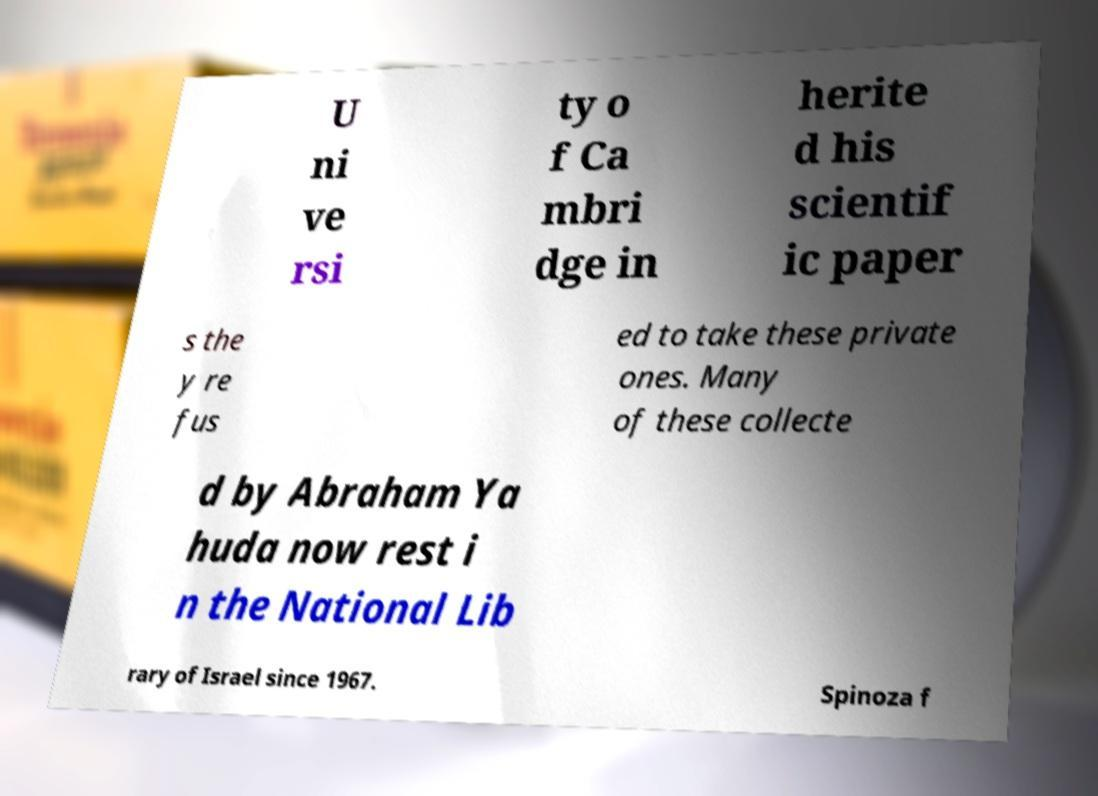What messages or text are displayed in this image? I need them in a readable, typed format. U ni ve rsi ty o f Ca mbri dge in herite d his scientif ic paper s the y re fus ed to take these private ones. Many of these collecte d by Abraham Ya huda now rest i n the National Lib rary of Israel since 1967. Spinoza f 